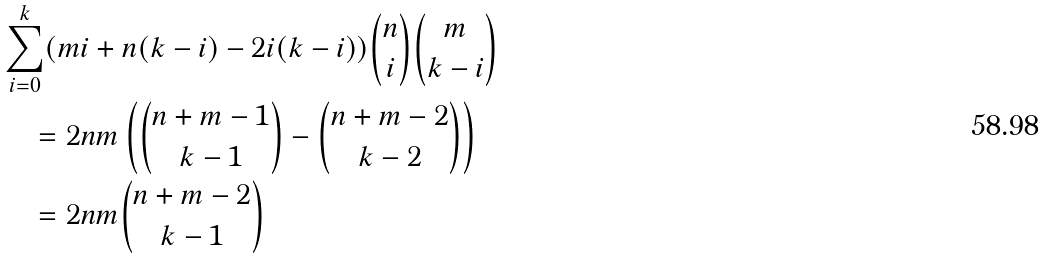<formula> <loc_0><loc_0><loc_500><loc_500>& \sum _ { i = 0 } ^ { k } ( m i + n ( k - i ) - 2 i ( k - i ) ) \binom { n } { i } \binom { m } { k - i } \\ & \quad = 2 n m \left ( \binom { n + m - 1 } { k - 1 } - \binom { n + m - 2 } { k - 2 } \right ) \\ & \quad = 2 n m \binom { n + m - 2 } { k - 1 }</formula> 